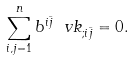Convert formula to latex. <formula><loc_0><loc_0><loc_500><loc_500>\sum _ { i , j = 1 } ^ { n } b ^ { i \bar { j } } \ v k _ { ; { i \bar { j } } } = 0 .</formula> 